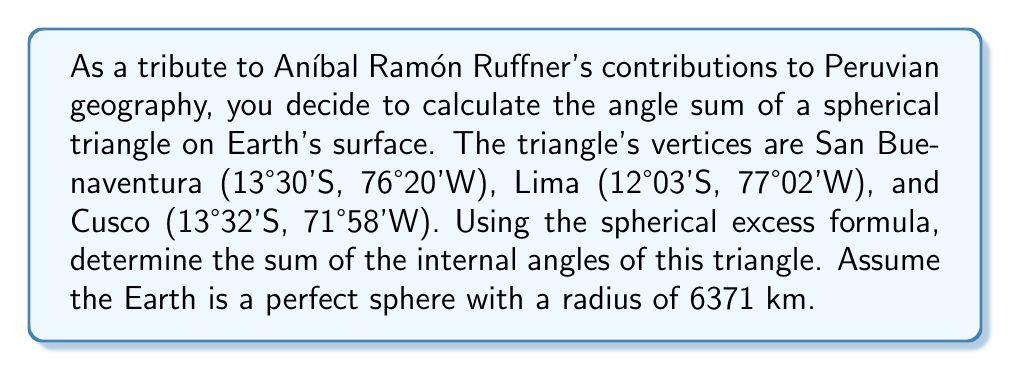Solve this math problem. Let's approach this step-by-step:

1) In spherical geometry, the sum of angles in a triangle is greater than 180°. The excess over 180° is called the spherical excess (E).

2) The spherical excess is related to the area (A) of the triangle and the radius (R) of the sphere by the formula:

   $$E = \frac{A}{R^2}$$

   where E is in radians.

3) To find the area, we can use l'Huilier's formula. First, we need to calculate the side lengths of the triangle.

4) To calculate the side lengths, we use the great circle distance formula:

   $$d = R \cdot \arccos(\sin\phi_1 \sin\phi_2 + \cos\phi_1 \cos\phi_2 \cos(\lambda_2 - \lambda_1))$$

   where $\phi$ is latitude and $\lambda$ is longitude in radians.

5) Converting coordinates to radians and calculating sides:
   San Buenaventura: $\phi_1 = -0.2356, \lambda_1 = -1.3323$
   Lima: $\phi_2 = -0.2103, \lambda_2 = -1.3439$
   Cusco: $\phi_3 = -0.2361, \lambda_3 = -1.2561$

   a = 132.7 km (San Buenaventura to Lima)
   b = 584.8 km (Lima to Cusco)
   c = 573.0 km (Cusco to San Buenaventura)

6) Now we can use l'Huilier's formula:

   $$\tan(\frac{E}{4}) = \sqrt{\tan(\frac{s}{2})\tan(\frac{s-a}{2})\tan(\frac{s-b}{2})\tan(\frac{s-c}{2})}$$

   where $s = \frac{a+b+c}{2}$ is the semi-perimeter.

7) Calculating:
   $s = 645.25$ km
   $E = 0.008291$ radians

8) Converting to degrees:
   $E = 0.4751°$

9) The sum of angles in the spherical triangle is:
   $180° + E = 180.4751°$
Answer: $180.4751°$ 